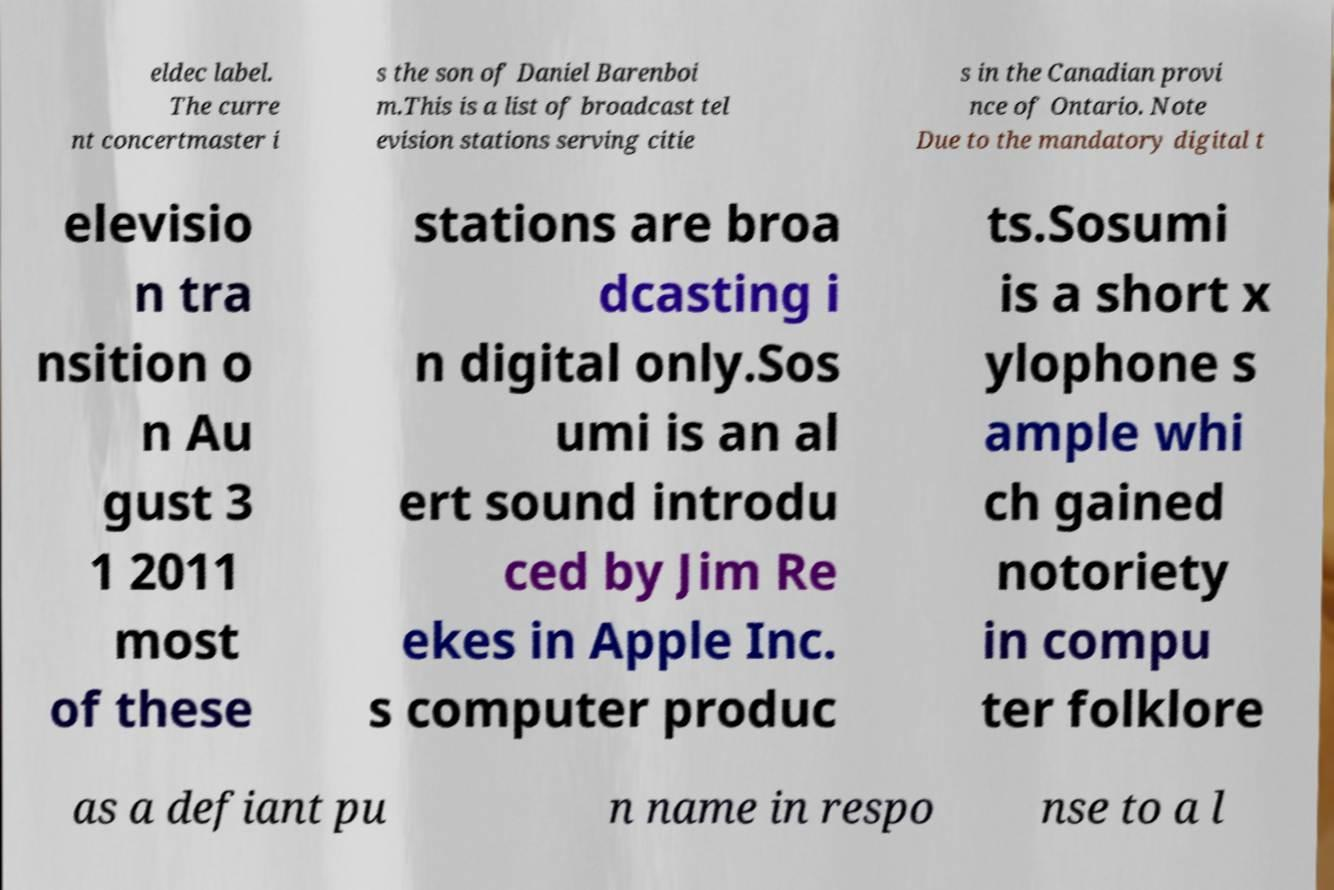What messages or text are displayed in this image? I need them in a readable, typed format. eldec label. The curre nt concertmaster i s the son of Daniel Barenboi m.This is a list of broadcast tel evision stations serving citie s in the Canadian provi nce of Ontario. Note Due to the mandatory digital t elevisio n tra nsition o n Au gust 3 1 2011 most of these stations are broa dcasting i n digital only.Sos umi is an al ert sound introdu ced by Jim Re ekes in Apple Inc. s computer produc ts.Sosumi is a short x ylophone s ample whi ch gained notoriety in compu ter folklore as a defiant pu n name in respo nse to a l 